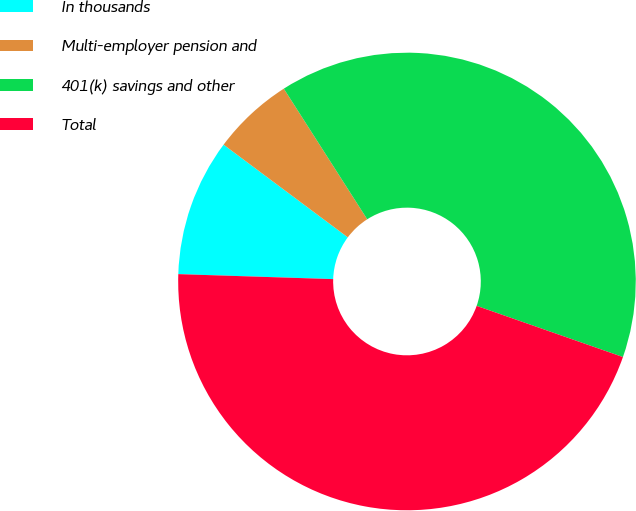Convert chart. <chart><loc_0><loc_0><loc_500><loc_500><pie_chart><fcel>In thousands<fcel>Multi-employer pension and<fcel>401(k) savings and other<fcel>Total<nl><fcel>9.69%<fcel>5.75%<fcel>39.4%<fcel>45.15%<nl></chart> 